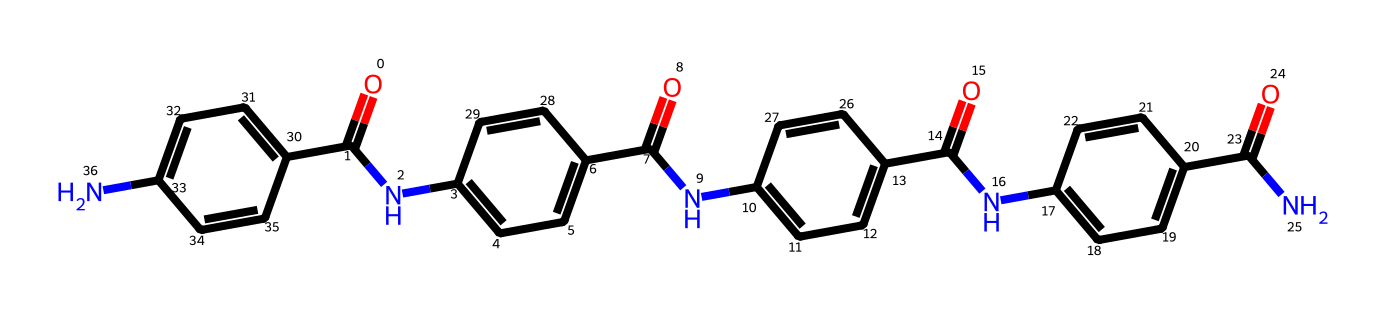What is the main functional group present in this chemical? The chemical structure contains multiple amide groups (C=O attached to N) visible in the repeating units. These are essential for forming the polymer chains characteristic of Kevlar.
Answer: amide How many aromatic rings are present in this structure? By visually inspecting the given structure, there are four distinct aromatic (benzene) rings, which are indicated by the alternating double bonds and the cyclic structure.
Answer: four What type of polymer is represented by this chemical? This structure is representative of an aramid fiber, specifically Kevlar, due to the amide linkages and long-chain structure that exhibit high strength and durability.
Answer: aramid What is the primary reason Kevlar is used in bulletproof vests? The polymer structure provides exceptionally high tensile strength, flexibility, and heat resistance, making it suitable for stopping bullets effectively.
Answer: tensile strength How many amide linkages are present in this structure? Counting the connections where a carbonyl (C=O) directly bonds to a nitrogen (N) shows that there are three amide linkages, which is characteristic of the polymer's repeating unit.
Answer: three What property of Kevlar is primarily enhanced by its polymeric structure? The polymeric structure enhances mechanical properties such as strength, which stems from the strong intermolecular forces and stability of the repeated amide units.
Answer: strength 